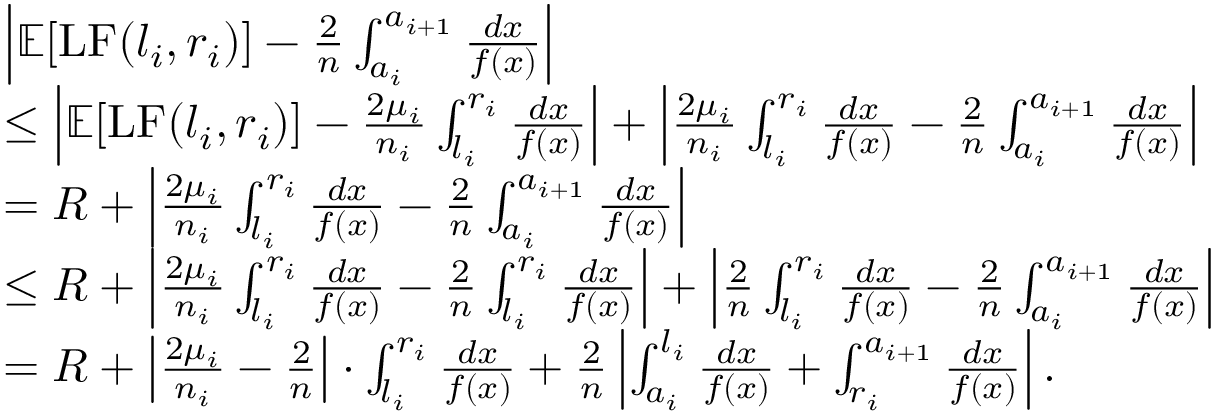<formula> <loc_0><loc_0><loc_500><loc_500>\begin{array} { r l } & { \left | \mathbb { E } [ L F ( l _ { i } , r _ { i } ) ] - \frac { 2 } { n } \int _ { a _ { i } } ^ { a _ { i + 1 } } \frac { d x } { f ( x ) } \right | } \\ & { \leq \left | \mathbb { E } [ L F ( l _ { i } , r _ { i } ) ] - \frac { 2 \mu _ { i } } { n _ { i } } \int _ { l _ { i } } ^ { r _ { i } } \frac { d x } { f ( x ) } \right | + \left | \frac { 2 \mu _ { i } } { n _ { i } } \int _ { l _ { i } } ^ { r _ { i } } \frac { d x } { f ( x ) } - \frac { 2 } { n } \int _ { a _ { i } } ^ { a _ { i + 1 } } \frac { d x } { f ( x ) } \right | } \\ & { = R + \left | \frac { 2 \mu _ { i } } { n _ { i } } \int _ { l _ { i } } ^ { r _ { i } } \frac { d x } { f ( x ) } - \frac { 2 } { n } \int _ { a _ { i } } ^ { a _ { i + 1 } } \frac { d x } { f ( x ) } \right | } \\ & { \leq R + \left | \frac { 2 \mu _ { i } } { n _ { i } } \int _ { l _ { i } } ^ { r _ { i } } \frac { d x } { f ( x ) } - \frac { 2 } { n } \int _ { l _ { i } } ^ { r _ { i } } \frac { d x } { f ( x ) } \right | + \left | \frac { 2 } { n } \int _ { l _ { i } } ^ { r _ { i } } \frac { d x } { f ( x ) } - \frac { 2 } { n } \int _ { a _ { i } } ^ { a _ { i + 1 } } \frac { d x } { f ( x ) } \right | } \\ & { = R + \left | \frac { 2 \mu _ { i } } { n _ { i } } - \frac { 2 } { n } \right | \cdot \int _ { l _ { i } } ^ { r _ { i } } \frac { d x } { f ( x ) } + \frac { 2 } { n } \left | \int _ { a _ { i } } ^ { l _ { i } } \frac { d x } { f ( x ) } + \int _ { r _ { i } } ^ { a _ { i + 1 } } \frac { d x } { f ( x ) } \right | . } \end{array}</formula> 